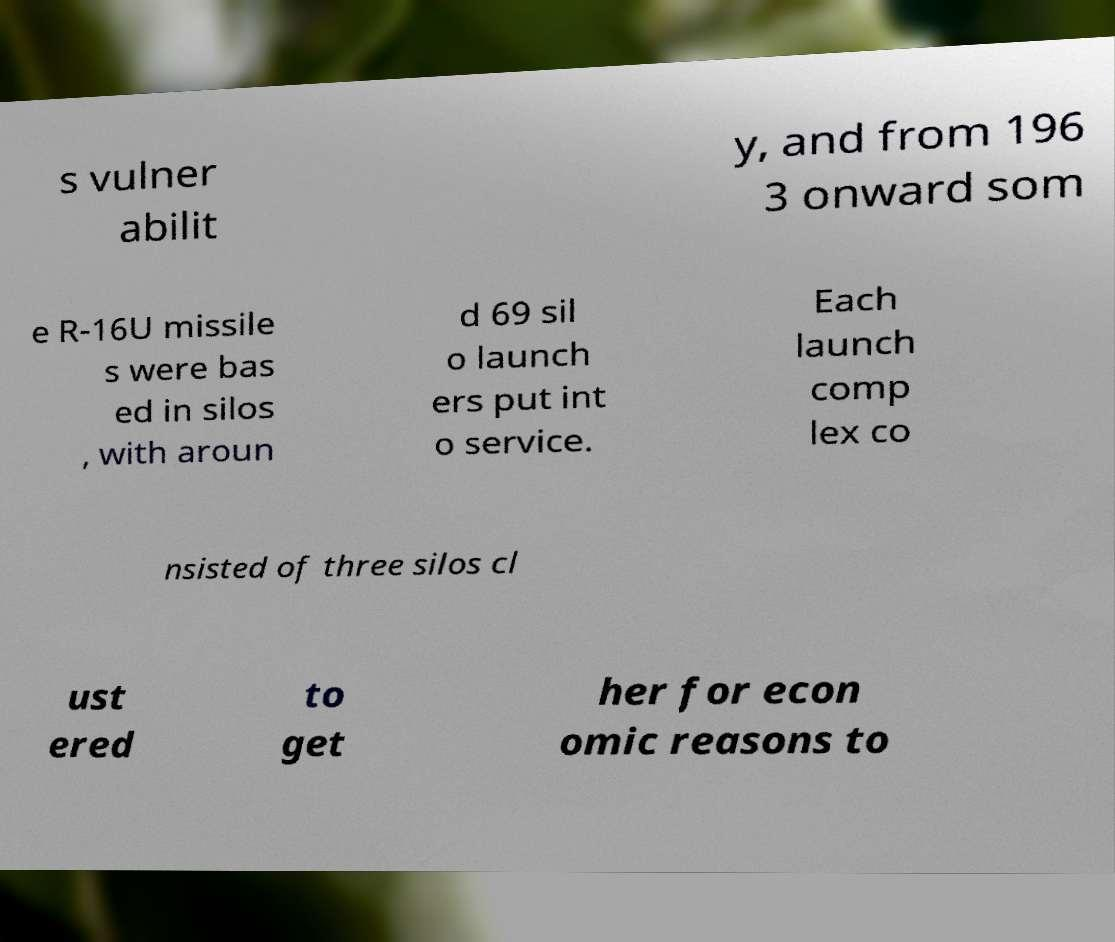For documentation purposes, I need the text within this image transcribed. Could you provide that? s vulner abilit y, and from 196 3 onward som e R-16U missile s were bas ed in silos , with aroun d 69 sil o launch ers put int o service. Each launch comp lex co nsisted of three silos cl ust ered to get her for econ omic reasons to 